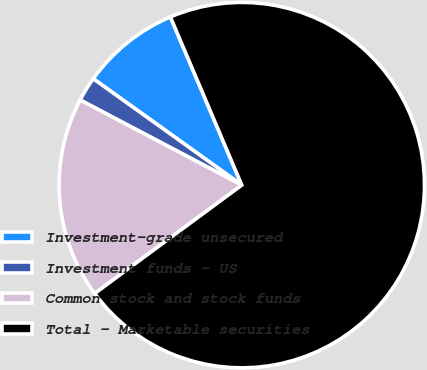<chart> <loc_0><loc_0><loc_500><loc_500><pie_chart><fcel>Investment-grade unsecured<fcel>Investment funds - US<fcel>Common stock and stock funds<fcel>Total - Marketable securities<nl><fcel>8.72%<fcel>2.18%<fcel>17.82%<fcel>71.29%<nl></chart> 